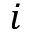<formula> <loc_0><loc_0><loc_500><loc_500>i</formula> 